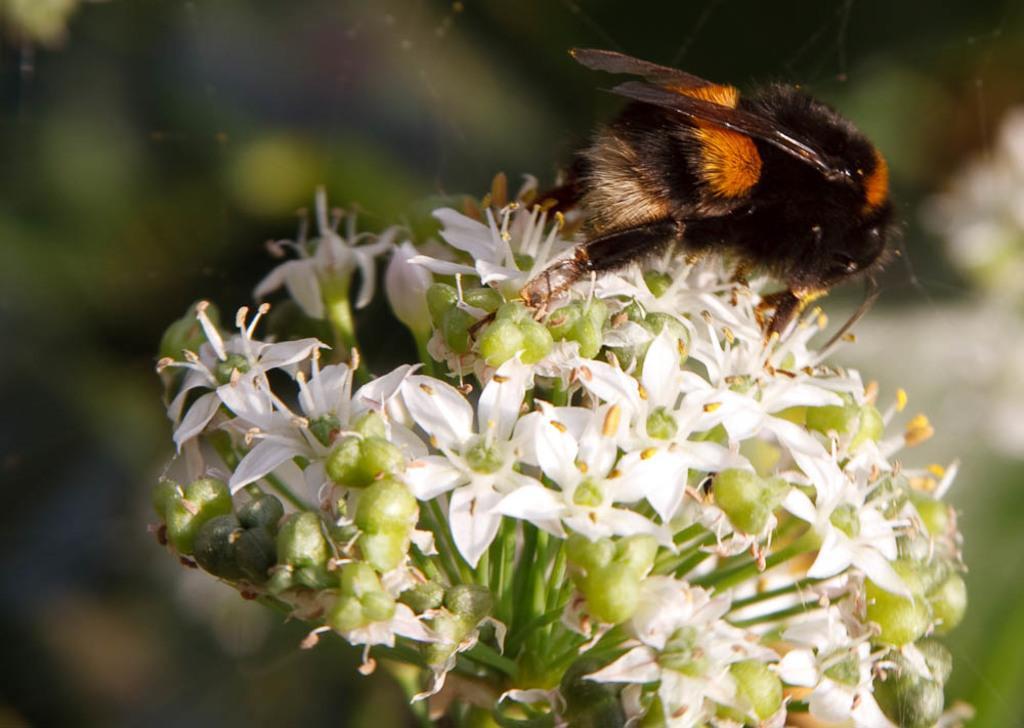In one or two sentences, can you explain what this image depicts? In this image, we can see an insect on the flowers. Background there is a blur view. Here we can see webs. 